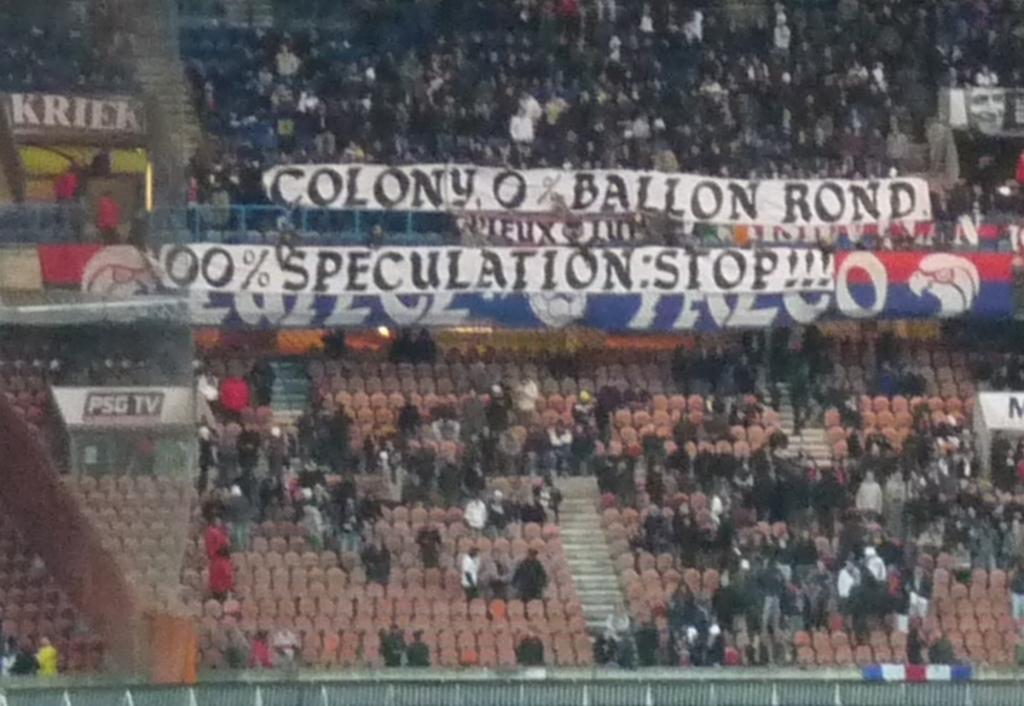<image>
Create a compact narrative representing the image presented. At a baseball game, people put up a sign that says "Colony, 0% Ballon Rond. 100% Speculation: Stop !!!" 